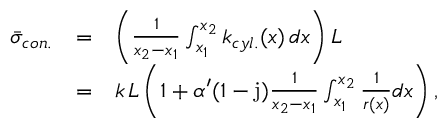<formula> <loc_0><loc_0><loc_500><loc_500>\begin{array} { l c l } { \bar { \sigma } _ { c o n . } } & { = } & { \left ( \frac { 1 } { x _ { 2 } - x _ { 1 } } \int _ { x _ { 1 } } ^ { x _ { 2 } } { k _ { c y l . } ( x ) \, d x } \right ) L } \\ & { = } & { k \, L \left ( 1 + \alpha ^ { \prime } ( 1 - j ) \frac { 1 } { x _ { 2 } - x _ { 1 } } \int _ { x _ { 1 } } ^ { x _ { 2 } } \frac { 1 } { r ( x ) } d x \right ) , } \end{array}</formula> 